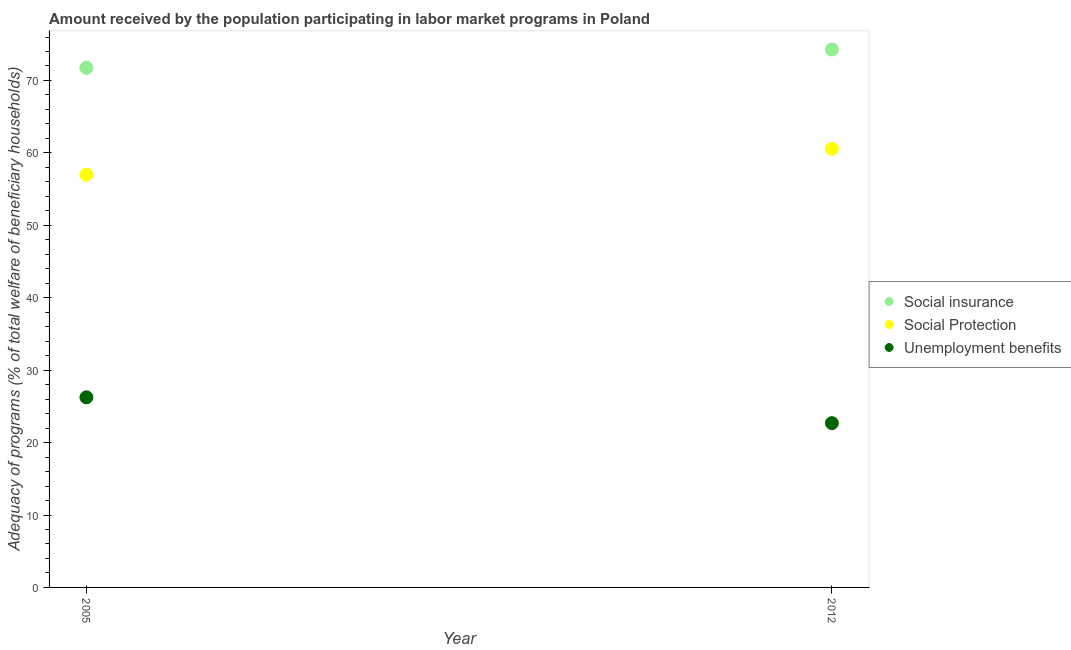How many different coloured dotlines are there?
Offer a very short reply. 3. Is the number of dotlines equal to the number of legend labels?
Keep it short and to the point. Yes. What is the amount received by the population participating in social protection programs in 2012?
Provide a short and direct response. 60.56. Across all years, what is the maximum amount received by the population participating in social protection programs?
Give a very brief answer. 60.56. Across all years, what is the minimum amount received by the population participating in social insurance programs?
Keep it short and to the point. 71.75. What is the total amount received by the population participating in social insurance programs in the graph?
Your answer should be compact. 146.03. What is the difference between the amount received by the population participating in unemployment benefits programs in 2005 and that in 2012?
Provide a succinct answer. 3.57. What is the difference between the amount received by the population participating in unemployment benefits programs in 2012 and the amount received by the population participating in social protection programs in 2005?
Ensure brevity in your answer.  -34.3. What is the average amount received by the population participating in unemployment benefits programs per year?
Provide a short and direct response. 24.47. In the year 2005, what is the difference between the amount received by the population participating in unemployment benefits programs and amount received by the population participating in social protection programs?
Make the answer very short. -30.74. In how many years, is the amount received by the population participating in unemployment benefits programs greater than 60 %?
Offer a very short reply. 0. What is the ratio of the amount received by the population participating in unemployment benefits programs in 2005 to that in 2012?
Give a very brief answer. 1.16. Is the amount received by the population participating in social insurance programs in 2005 less than that in 2012?
Your response must be concise. Yes. In how many years, is the amount received by the population participating in social insurance programs greater than the average amount received by the population participating in social insurance programs taken over all years?
Provide a short and direct response. 1. Does the amount received by the population participating in social protection programs monotonically increase over the years?
Your answer should be very brief. Yes. Is the amount received by the population participating in unemployment benefits programs strictly greater than the amount received by the population participating in social protection programs over the years?
Your response must be concise. No. How many dotlines are there?
Ensure brevity in your answer.  3. How many years are there in the graph?
Give a very brief answer. 2. Does the graph contain any zero values?
Provide a succinct answer. No. How are the legend labels stacked?
Provide a short and direct response. Vertical. What is the title of the graph?
Offer a very short reply. Amount received by the population participating in labor market programs in Poland. Does "Tertiary" appear as one of the legend labels in the graph?
Make the answer very short. No. What is the label or title of the X-axis?
Your response must be concise. Year. What is the label or title of the Y-axis?
Provide a succinct answer. Adequacy of programs (% of total welfare of beneficiary households). What is the Adequacy of programs (% of total welfare of beneficiary households) of Social insurance in 2005?
Your answer should be compact. 71.75. What is the Adequacy of programs (% of total welfare of beneficiary households) in Social Protection in 2005?
Your response must be concise. 56.99. What is the Adequacy of programs (% of total welfare of beneficiary households) of Unemployment benefits in 2005?
Your response must be concise. 26.25. What is the Adequacy of programs (% of total welfare of beneficiary households) in Social insurance in 2012?
Ensure brevity in your answer.  74.28. What is the Adequacy of programs (% of total welfare of beneficiary households) in Social Protection in 2012?
Your answer should be very brief. 60.56. What is the Adequacy of programs (% of total welfare of beneficiary households) in Unemployment benefits in 2012?
Provide a short and direct response. 22.68. Across all years, what is the maximum Adequacy of programs (% of total welfare of beneficiary households) in Social insurance?
Your response must be concise. 74.28. Across all years, what is the maximum Adequacy of programs (% of total welfare of beneficiary households) in Social Protection?
Ensure brevity in your answer.  60.56. Across all years, what is the maximum Adequacy of programs (% of total welfare of beneficiary households) of Unemployment benefits?
Make the answer very short. 26.25. Across all years, what is the minimum Adequacy of programs (% of total welfare of beneficiary households) of Social insurance?
Make the answer very short. 71.75. Across all years, what is the minimum Adequacy of programs (% of total welfare of beneficiary households) of Social Protection?
Your answer should be compact. 56.99. Across all years, what is the minimum Adequacy of programs (% of total welfare of beneficiary households) in Unemployment benefits?
Provide a short and direct response. 22.68. What is the total Adequacy of programs (% of total welfare of beneficiary households) in Social insurance in the graph?
Ensure brevity in your answer.  146.03. What is the total Adequacy of programs (% of total welfare of beneficiary households) of Social Protection in the graph?
Offer a terse response. 117.54. What is the total Adequacy of programs (% of total welfare of beneficiary households) in Unemployment benefits in the graph?
Provide a succinct answer. 48.93. What is the difference between the Adequacy of programs (% of total welfare of beneficiary households) in Social insurance in 2005 and that in 2012?
Offer a very short reply. -2.52. What is the difference between the Adequacy of programs (% of total welfare of beneficiary households) in Social Protection in 2005 and that in 2012?
Give a very brief answer. -3.57. What is the difference between the Adequacy of programs (% of total welfare of beneficiary households) in Unemployment benefits in 2005 and that in 2012?
Provide a short and direct response. 3.57. What is the difference between the Adequacy of programs (% of total welfare of beneficiary households) of Social insurance in 2005 and the Adequacy of programs (% of total welfare of beneficiary households) of Social Protection in 2012?
Your answer should be compact. 11.2. What is the difference between the Adequacy of programs (% of total welfare of beneficiary households) in Social insurance in 2005 and the Adequacy of programs (% of total welfare of beneficiary households) in Unemployment benefits in 2012?
Provide a short and direct response. 49.07. What is the difference between the Adequacy of programs (% of total welfare of beneficiary households) of Social Protection in 2005 and the Adequacy of programs (% of total welfare of beneficiary households) of Unemployment benefits in 2012?
Keep it short and to the point. 34.3. What is the average Adequacy of programs (% of total welfare of beneficiary households) in Social insurance per year?
Offer a terse response. 73.01. What is the average Adequacy of programs (% of total welfare of beneficiary households) of Social Protection per year?
Your response must be concise. 58.77. What is the average Adequacy of programs (% of total welfare of beneficiary households) of Unemployment benefits per year?
Keep it short and to the point. 24.47. In the year 2005, what is the difference between the Adequacy of programs (% of total welfare of beneficiary households) in Social insurance and Adequacy of programs (% of total welfare of beneficiary households) in Social Protection?
Your answer should be compact. 14.77. In the year 2005, what is the difference between the Adequacy of programs (% of total welfare of beneficiary households) in Social insurance and Adequacy of programs (% of total welfare of beneficiary households) in Unemployment benefits?
Give a very brief answer. 45.5. In the year 2005, what is the difference between the Adequacy of programs (% of total welfare of beneficiary households) of Social Protection and Adequacy of programs (% of total welfare of beneficiary households) of Unemployment benefits?
Keep it short and to the point. 30.74. In the year 2012, what is the difference between the Adequacy of programs (% of total welfare of beneficiary households) of Social insurance and Adequacy of programs (% of total welfare of beneficiary households) of Social Protection?
Offer a very short reply. 13.72. In the year 2012, what is the difference between the Adequacy of programs (% of total welfare of beneficiary households) of Social insurance and Adequacy of programs (% of total welfare of beneficiary households) of Unemployment benefits?
Your answer should be very brief. 51.59. In the year 2012, what is the difference between the Adequacy of programs (% of total welfare of beneficiary households) of Social Protection and Adequacy of programs (% of total welfare of beneficiary households) of Unemployment benefits?
Give a very brief answer. 37.87. What is the ratio of the Adequacy of programs (% of total welfare of beneficiary households) in Social Protection in 2005 to that in 2012?
Keep it short and to the point. 0.94. What is the ratio of the Adequacy of programs (% of total welfare of beneficiary households) of Unemployment benefits in 2005 to that in 2012?
Provide a succinct answer. 1.16. What is the difference between the highest and the second highest Adequacy of programs (% of total welfare of beneficiary households) of Social insurance?
Make the answer very short. 2.52. What is the difference between the highest and the second highest Adequacy of programs (% of total welfare of beneficiary households) in Social Protection?
Keep it short and to the point. 3.57. What is the difference between the highest and the second highest Adequacy of programs (% of total welfare of beneficiary households) in Unemployment benefits?
Provide a short and direct response. 3.57. What is the difference between the highest and the lowest Adequacy of programs (% of total welfare of beneficiary households) of Social insurance?
Offer a terse response. 2.52. What is the difference between the highest and the lowest Adequacy of programs (% of total welfare of beneficiary households) in Social Protection?
Make the answer very short. 3.57. What is the difference between the highest and the lowest Adequacy of programs (% of total welfare of beneficiary households) in Unemployment benefits?
Your response must be concise. 3.57. 